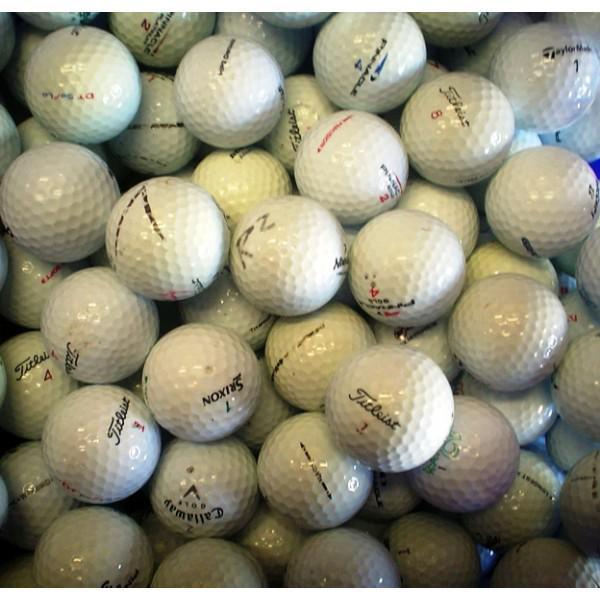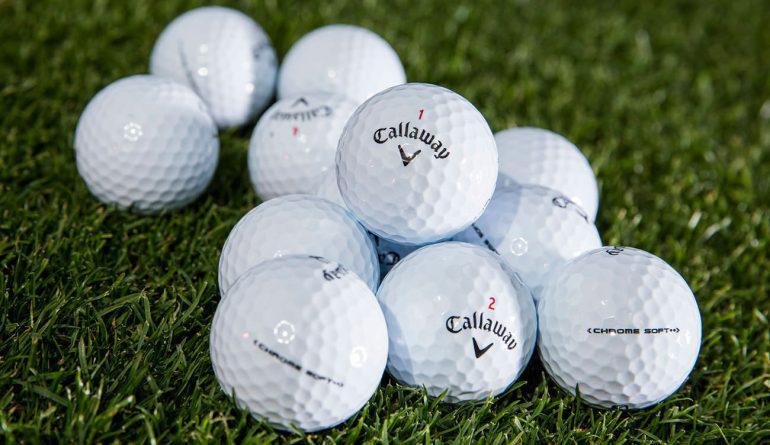The first image is the image on the left, the second image is the image on the right. Assess this claim about the two images: "An image shows golf balls in some type of square shape, on a grass type background.". Correct or not? Answer yes or no. No. The first image is the image on the left, the second image is the image on the right. Considering the images on both sides, is "Both images show golf balls on a grass-type background." valid? Answer yes or no. No. The first image is the image on the left, the second image is the image on the right. Analyze the images presented: Is the assertion "At least one of the images do not contain grass." valid? Answer yes or no. Yes. The first image is the image on the left, the second image is the image on the right. Evaluate the accuracy of this statement regarding the images: "There is one golf ball sitting on top of other balls in the image on the right.". Is it true? Answer yes or no. Yes. 